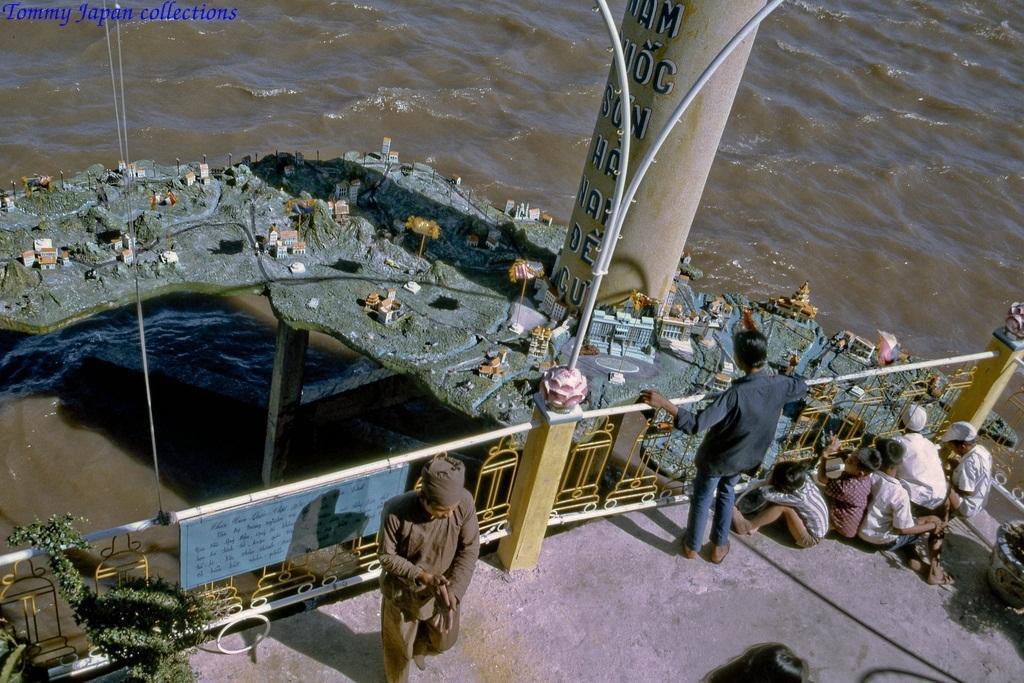In one or two sentences, can you explain what this image depicts? In this picture there are people and we can see railing, pillars, poles and board. We can see miniatures, water and plants. 